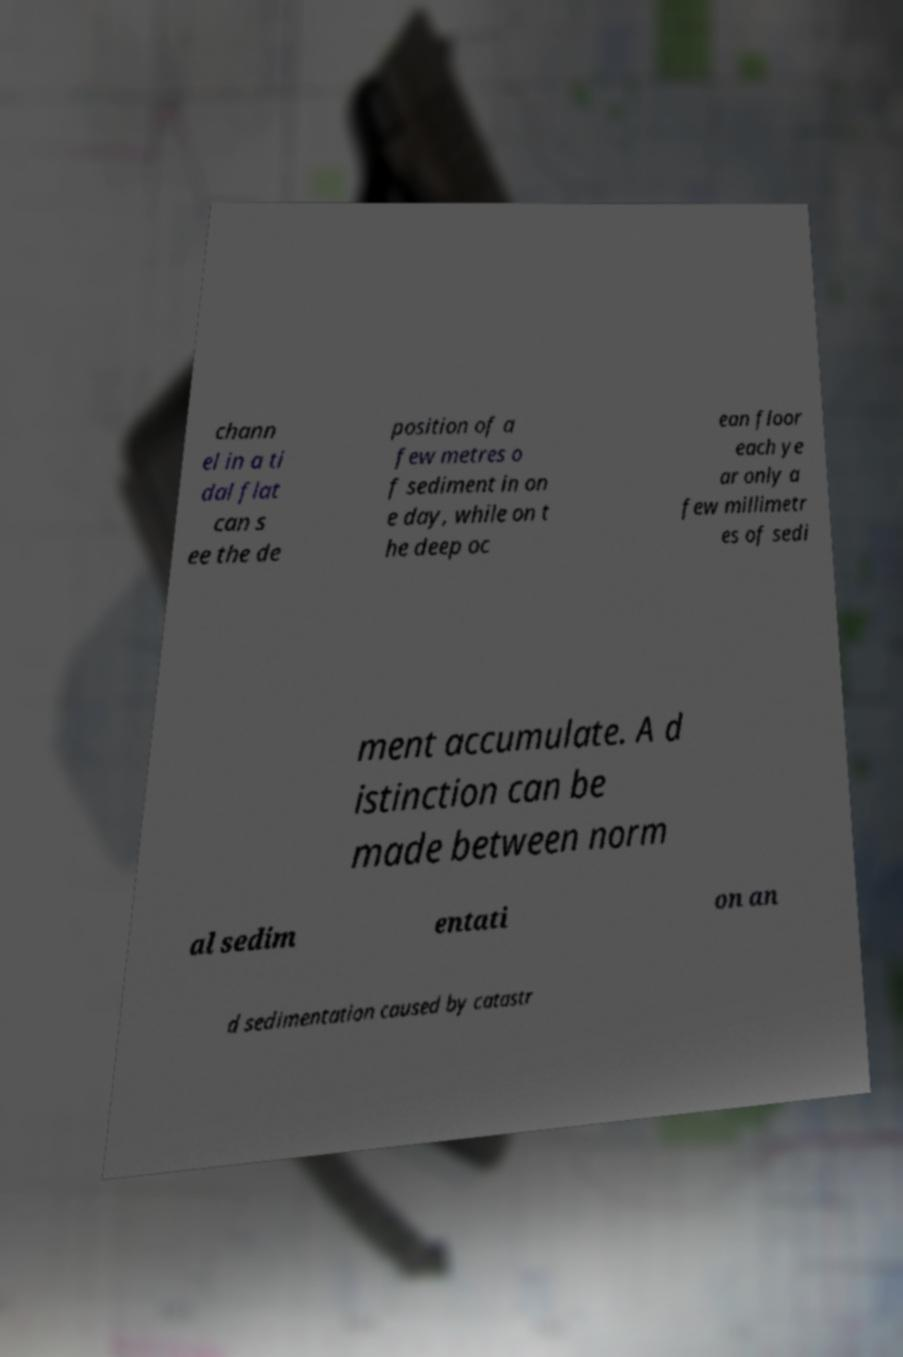What messages or text are displayed in this image? I need them in a readable, typed format. chann el in a ti dal flat can s ee the de position of a few metres o f sediment in on e day, while on t he deep oc ean floor each ye ar only a few millimetr es of sedi ment accumulate. A d istinction can be made between norm al sedim entati on an d sedimentation caused by catastr 